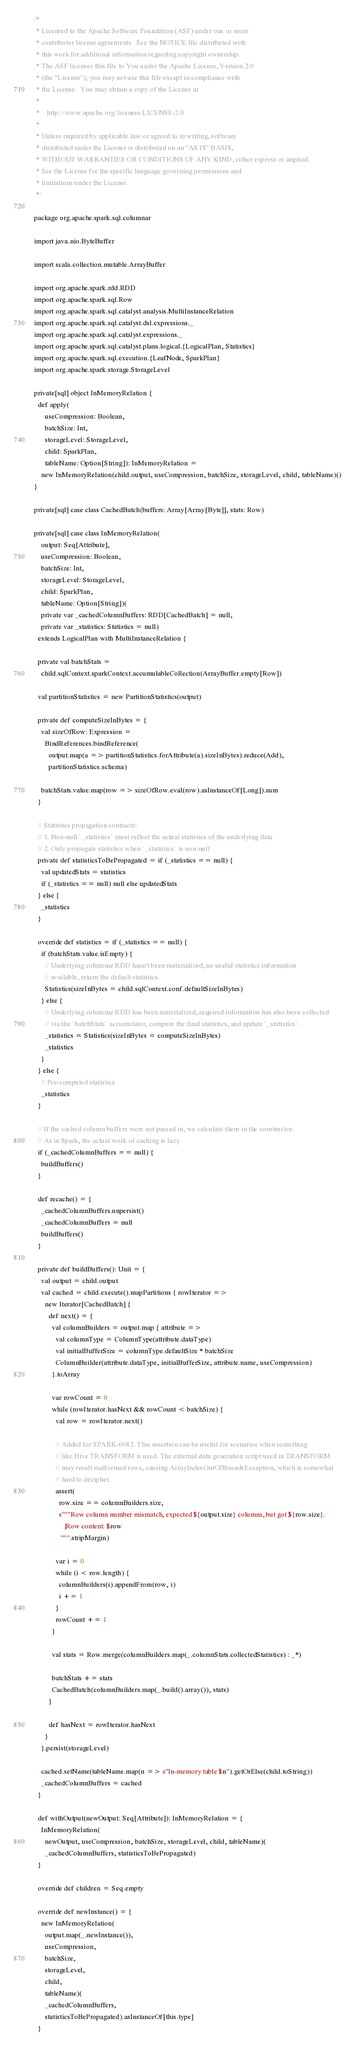<code> <loc_0><loc_0><loc_500><loc_500><_Scala_>/*
 * Licensed to the Apache Software Foundation (ASF) under one or more
 * contributor license agreements.  See the NOTICE file distributed with
 * this work for additional information regarding copyright ownership.
 * The ASF licenses this file to You under the Apache License, Version 2.0
 * (the "License"); you may not use this file except in compliance with
 * the License.  You may obtain a copy of the License at
 *
 *    http://www.apache.org/licenses/LICENSE-2.0
 *
 * Unless required by applicable law or agreed to in writing, software
 * distributed under the License is distributed on an "AS IS" BASIS,
 * WITHOUT WARRANTIES OR CONDITIONS OF ANY KIND, either express or implied.
 * See the License for the specific language governing permissions and
 * limitations under the License.
 */

package org.apache.spark.sql.columnar

import java.nio.ByteBuffer

import scala.collection.mutable.ArrayBuffer

import org.apache.spark.rdd.RDD
import org.apache.spark.sql.Row
import org.apache.spark.sql.catalyst.analysis.MultiInstanceRelation
import org.apache.spark.sql.catalyst.dsl.expressions._
import org.apache.spark.sql.catalyst.expressions._
import org.apache.spark.sql.catalyst.plans.logical.{LogicalPlan, Statistics}
import org.apache.spark.sql.execution.{LeafNode, SparkPlan}
import org.apache.spark.storage.StorageLevel

private[sql] object InMemoryRelation {
  def apply(
      useCompression: Boolean,
      batchSize: Int,
      storageLevel: StorageLevel,
      child: SparkPlan,
      tableName: Option[String]): InMemoryRelation =
    new InMemoryRelation(child.output, useCompression, batchSize, storageLevel, child, tableName)()
}

private[sql] case class CachedBatch(buffers: Array[Array[Byte]], stats: Row)

private[sql] case class InMemoryRelation(
    output: Seq[Attribute],
    useCompression: Boolean,
    batchSize: Int,
    storageLevel: StorageLevel,
    child: SparkPlan,
    tableName: Option[String])(
    private var _cachedColumnBuffers: RDD[CachedBatch] = null,
    private var _statistics: Statistics = null)
  extends LogicalPlan with MultiInstanceRelation {

  private val batchStats =
    child.sqlContext.sparkContext.accumulableCollection(ArrayBuffer.empty[Row])

  val partitionStatistics = new PartitionStatistics(output)

  private def computeSizeInBytes = {
    val sizeOfRow: Expression =
      BindReferences.bindReference(
        output.map(a => partitionStatistics.forAttribute(a).sizeInBytes).reduce(Add),
        partitionStatistics.schema)

    batchStats.value.map(row => sizeOfRow.eval(row).asInstanceOf[Long]).sum
  }

  // Statistics propagation contracts:
  // 1. Non-null `_statistics` must reflect the actual statistics of the underlying data
  // 2. Only propagate statistics when `_statistics` is non-null
  private def statisticsToBePropagated = if (_statistics == null) {
    val updatedStats = statistics
    if (_statistics == null) null else updatedStats
  } else {
    _statistics
  }

  override def statistics = if (_statistics == null) {
    if (batchStats.value.isEmpty) {
      // Underlying columnar RDD hasn't been materialized, no useful statistics information
      // available, return the default statistics.
      Statistics(sizeInBytes = child.sqlContext.conf.defaultSizeInBytes)
    } else {
      // Underlying columnar RDD has been materialized, required information has also been collected
      // via the `batchStats` accumulator, compute the final statistics, and update `_statistics`.
      _statistics = Statistics(sizeInBytes = computeSizeInBytes)
      _statistics
    }
  } else {
    // Pre-computed statistics
    _statistics
  }

  // If the cached column buffers were not passed in, we calculate them in the constructor.
  // As in Spark, the actual work of caching is lazy.
  if (_cachedColumnBuffers == null) {
    buildBuffers()
  }

  def recache() = {
    _cachedColumnBuffers.unpersist()
    _cachedColumnBuffers = null
    buildBuffers()
  }

  private def buildBuffers(): Unit = {
    val output = child.output
    val cached = child.execute().mapPartitions { rowIterator =>
      new Iterator[CachedBatch] {
        def next() = {
          val columnBuilders = output.map { attribute =>
            val columnType = ColumnType(attribute.dataType)
            val initialBufferSize = columnType.defaultSize * batchSize
            ColumnBuilder(attribute.dataType, initialBufferSize, attribute.name, useCompression)
          }.toArray

          var rowCount = 0
          while (rowIterator.hasNext && rowCount < batchSize) {
            val row = rowIterator.next()

            // Added for SPARK-6082. This assertion can be useful for scenarios when something
            // like Hive TRANSFORM is used. The external data generation script used in TRANSFORM
            // may result malformed rows, causing ArrayIndexOutOfBoundsException, which is somewhat
            // hard to decipher.
            assert(
              row.size == columnBuilders.size,
              s"""Row column number mismatch, expected ${output.size} columns, but got ${row.size}.
                 |Row content: $row
               """.stripMargin)

            var i = 0
            while (i < row.length) {
              columnBuilders(i).appendFrom(row, i)
              i += 1
            }
            rowCount += 1
          }

          val stats = Row.merge(columnBuilders.map(_.columnStats.collectedStatistics) : _*)

          batchStats += stats
          CachedBatch(columnBuilders.map(_.build().array()), stats)
        }

        def hasNext = rowIterator.hasNext
      }
    }.persist(storageLevel)

    cached.setName(tableName.map(n => s"In-memory table $n").getOrElse(child.toString))
    _cachedColumnBuffers = cached
  }

  def withOutput(newOutput: Seq[Attribute]): InMemoryRelation = {
    InMemoryRelation(
      newOutput, useCompression, batchSize, storageLevel, child, tableName)(
      _cachedColumnBuffers, statisticsToBePropagated)
  }

  override def children = Seq.empty

  override def newInstance() = {
    new InMemoryRelation(
      output.map(_.newInstance()),
      useCompression,
      batchSize,
      storageLevel,
      child,
      tableName)(
      _cachedColumnBuffers,
      statisticsToBePropagated).asInstanceOf[this.type]
  }
</code> 